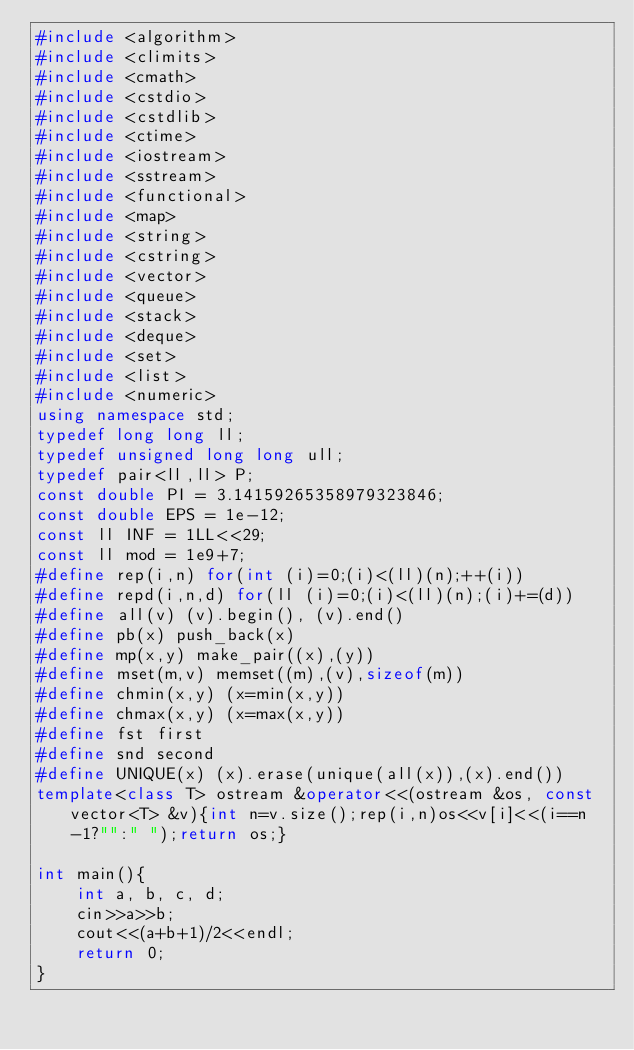<code> <loc_0><loc_0><loc_500><loc_500><_C++_>#include <algorithm>
#include <climits>
#include <cmath>
#include <cstdio>
#include <cstdlib>
#include <ctime>
#include <iostream>
#include <sstream>
#include <functional>
#include <map>
#include <string>
#include <cstring>
#include <vector>
#include <queue>
#include <stack>
#include <deque>
#include <set>
#include <list>
#include <numeric>
using namespace std;
typedef long long ll;
typedef unsigned long long ull;
typedef pair<ll,ll> P;
const double PI = 3.14159265358979323846;
const double EPS = 1e-12;
const ll INF = 1LL<<29;
const ll mod = 1e9+7;
#define rep(i,n) for(int (i)=0;(i)<(ll)(n);++(i))
#define repd(i,n,d) for(ll (i)=0;(i)<(ll)(n);(i)+=(d))
#define all(v) (v).begin(), (v).end()
#define pb(x) push_back(x)
#define mp(x,y) make_pair((x),(y))
#define mset(m,v) memset((m),(v),sizeof(m))
#define chmin(x,y) (x=min(x,y))
#define chmax(x,y) (x=max(x,y))
#define fst first
#define snd second
#define UNIQUE(x) (x).erase(unique(all(x)),(x).end())
template<class T> ostream &operator<<(ostream &os, const vector<T> &v){int n=v.size();rep(i,n)os<<v[i]<<(i==n-1?"":" ");return os;}

int main(){
	int a, b, c, d;
	cin>>a>>b;
	cout<<(a+b+1)/2<<endl;
	return 0;
}
</code> 